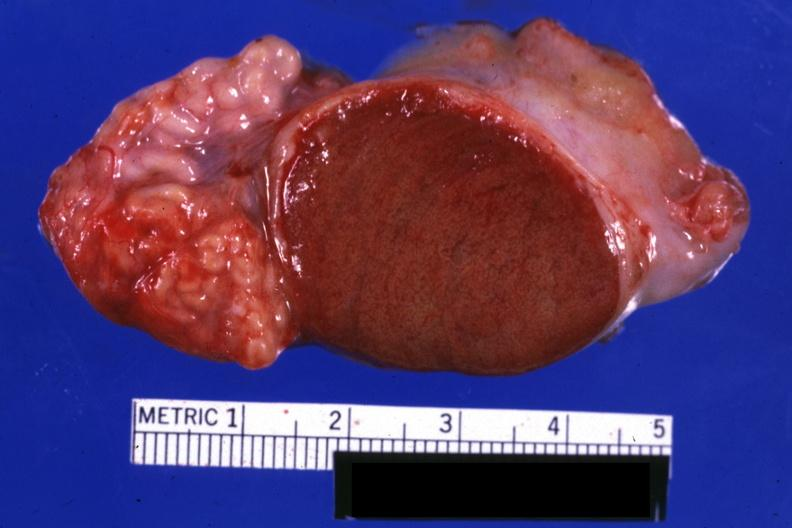does this image show excellent close-up view sliced open testicle with intact epididymis?
Answer the question using a single word or phrase. Yes 